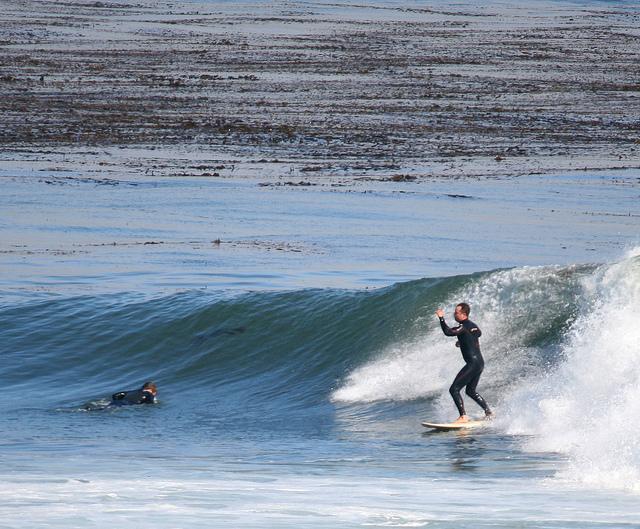How many red bird in this image?
Give a very brief answer. 0. 